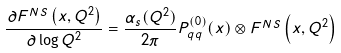<formula> <loc_0><loc_0><loc_500><loc_500>\frac { \partial F ^ { N S } \left ( x , Q ^ { 2 } \right ) } { \partial \log Q ^ { 2 } } = \frac { \alpha _ { s } ( Q ^ { 2 } ) } { 2 \pi } P _ { q q } ^ { ( 0 ) } ( x ) \otimes F ^ { N S } \left ( x , Q ^ { 2 } \right )</formula> 